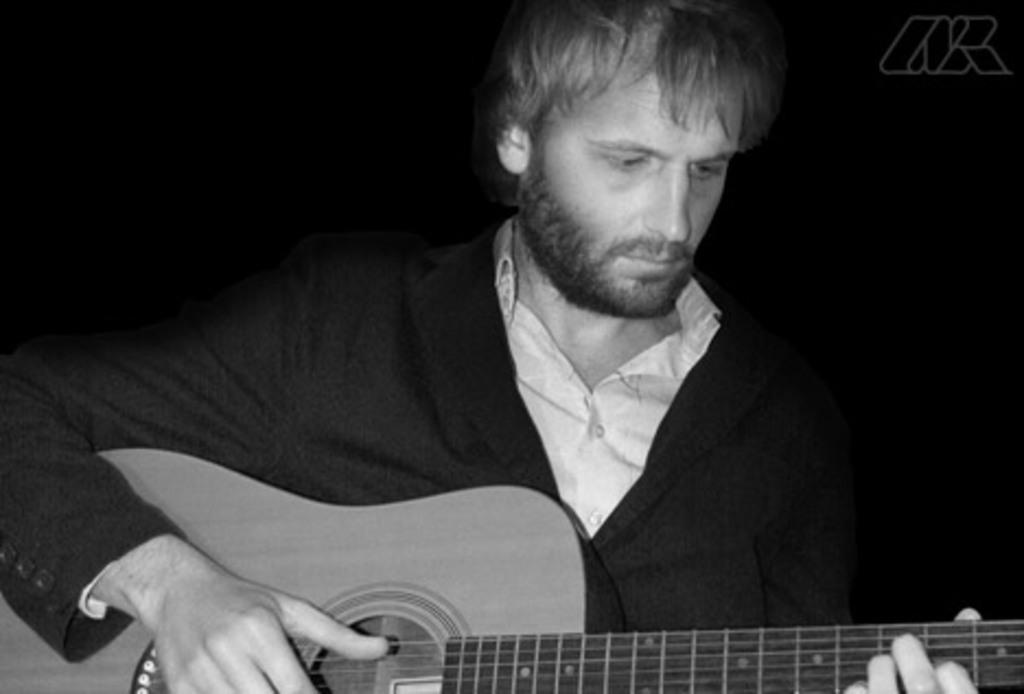What is the main subject of the image? There is a person in the image. What is the person wearing? The person is wearing a suit. What activity is the person engaged in? The person is playing a guitar. What is the color of the background in the image? The background in the image is black. Can you see any art pieces displayed on the window in the image? There is no window present in the image, and therefore no art pieces can be seen. 